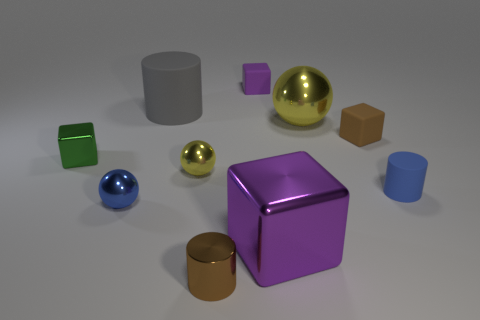Is there a tiny metal object of the same color as the big metal sphere?
Provide a succinct answer. Yes. Does the matte block that is in front of the gray matte cylinder have the same size as the tiny yellow thing?
Offer a terse response. Yes. What color is the shiny cylinder?
Provide a short and direct response. Brown. There is a tiny matte cube that is to the left of the purple block that is in front of the gray rubber cylinder; what color is it?
Provide a short and direct response. Purple. Is there a large purple object made of the same material as the big cube?
Provide a short and direct response. No. What is the material of the cylinder that is behind the brown rubber cube on the right side of the large yellow metallic sphere?
Provide a succinct answer. Rubber. How many blue things have the same shape as the big gray object?
Keep it short and to the point. 1. There is a small green metallic thing; what shape is it?
Ensure brevity in your answer.  Cube. Are there fewer big spheres than yellow objects?
Your answer should be very brief. Yes. What material is the big object that is the same shape as the small brown matte thing?
Give a very brief answer. Metal. 